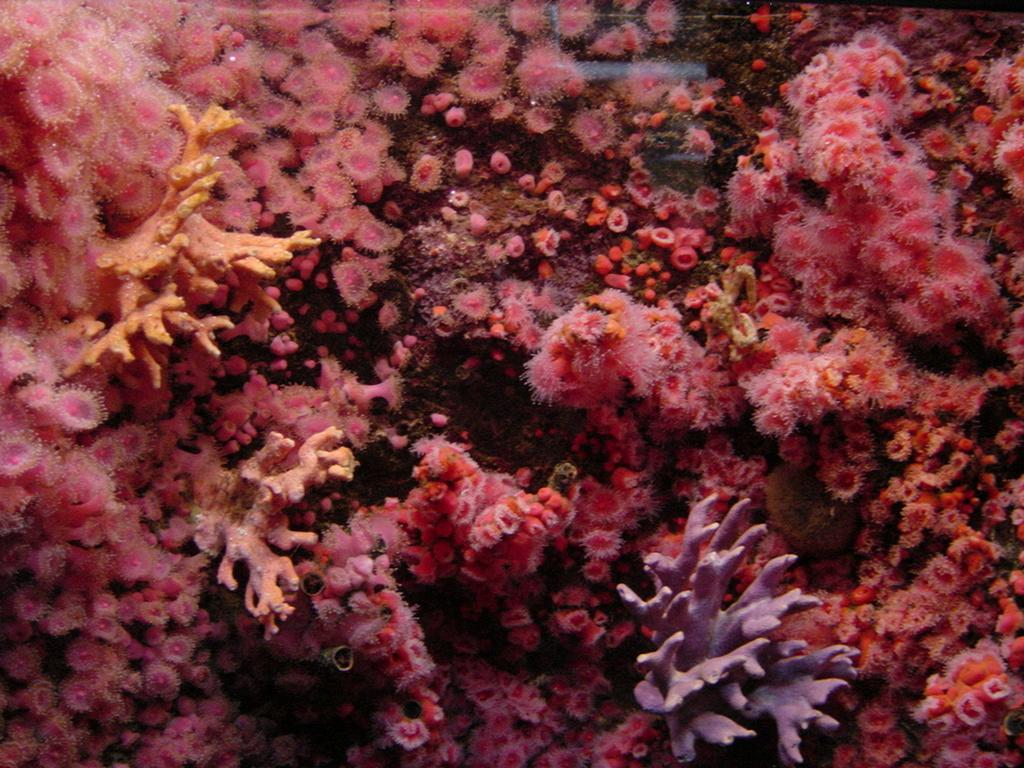What type of environment is depicted in the image? The image is an underwater image. What colors are predominant in the image? The colors in the image are pink and violet. Can you see a robin stitching a piece of fabric in the image? No, there is no robin or fabric present in the image, as it is an underwater scene with pink and violet colors. 